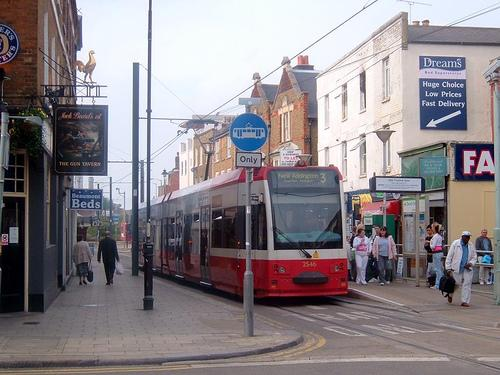In which location does this bus run? city 